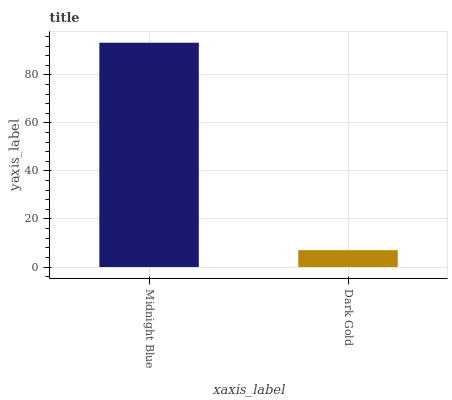Is Dark Gold the minimum?
Answer yes or no. Yes. Is Midnight Blue the maximum?
Answer yes or no. Yes. Is Dark Gold the maximum?
Answer yes or no. No. Is Midnight Blue greater than Dark Gold?
Answer yes or no. Yes. Is Dark Gold less than Midnight Blue?
Answer yes or no. Yes. Is Dark Gold greater than Midnight Blue?
Answer yes or no. No. Is Midnight Blue less than Dark Gold?
Answer yes or no. No. Is Midnight Blue the high median?
Answer yes or no. Yes. Is Dark Gold the low median?
Answer yes or no. Yes. Is Dark Gold the high median?
Answer yes or no. No. Is Midnight Blue the low median?
Answer yes or no. No. 